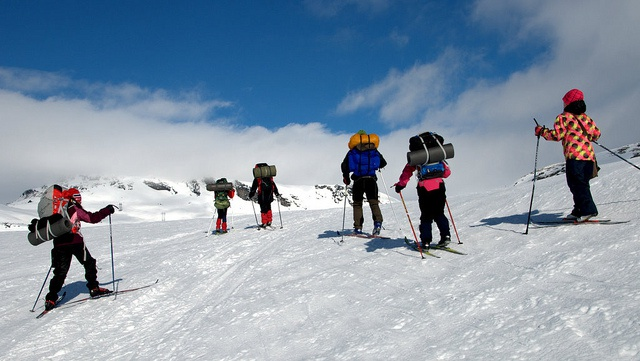Describe the objects in this image and their specific colors. I can see people in darkblue, black, gray, darkgray, and maroon tones, people in darkblue, black, gray, darkgray, and maroon tones, people in darkblue, black, maroon, salmon, and brown tones, people in darkblue, black, navy, red, and lightgray tones, and backpack in darkblue, black, gray, navy, and darkgray tones in this image. 